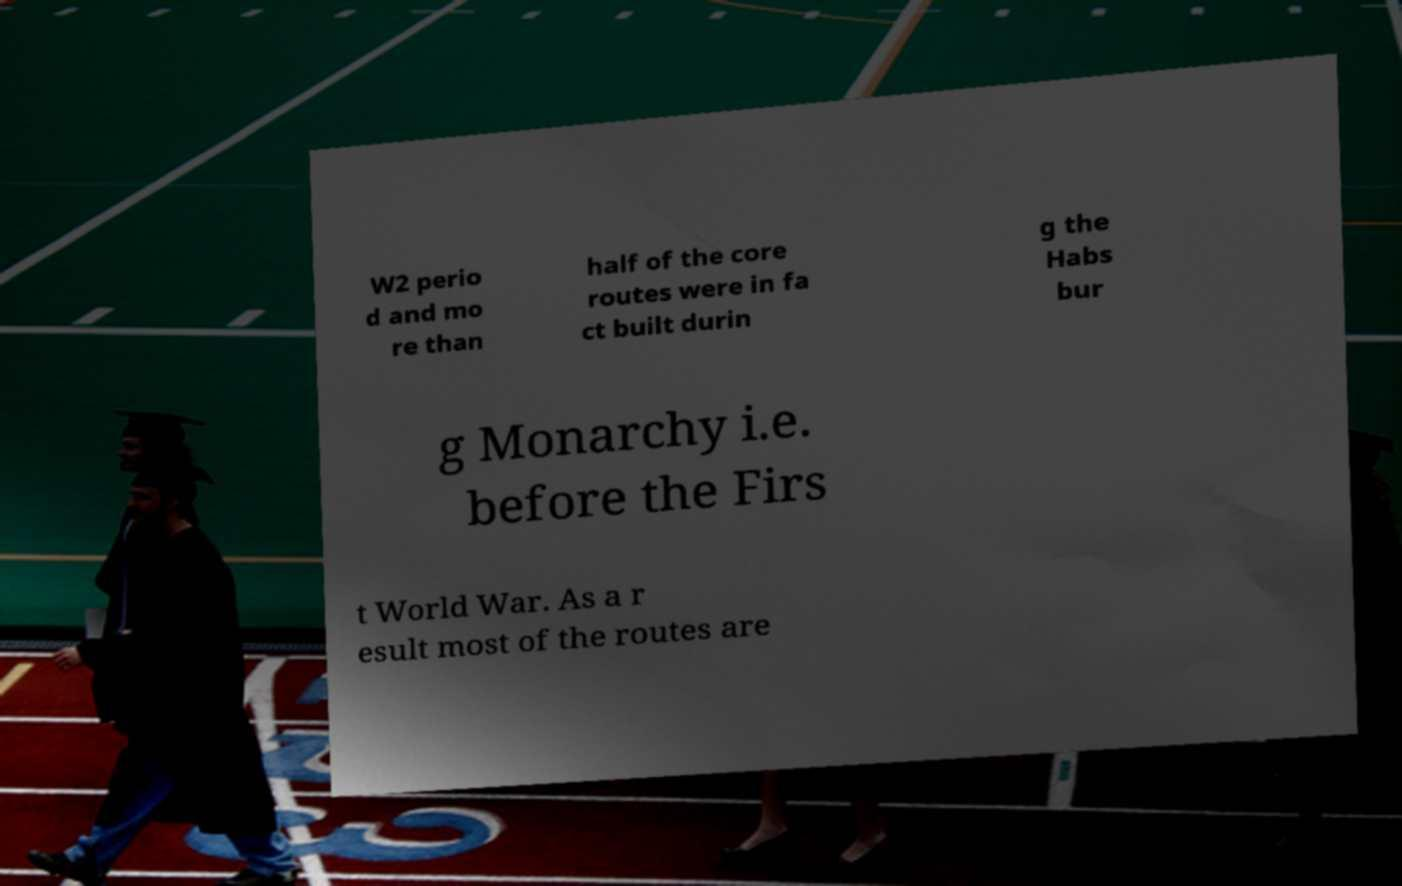Can you read and provide the text displayed in the image?This photo seems to have some interesting text. Can you extract and type it out for me? W2 perio d and mo re than half of the core routes were in fa ct built durin g the Habs bur g Monarchy i.e. before the Firs t World War. As a r esult most of the routes are 